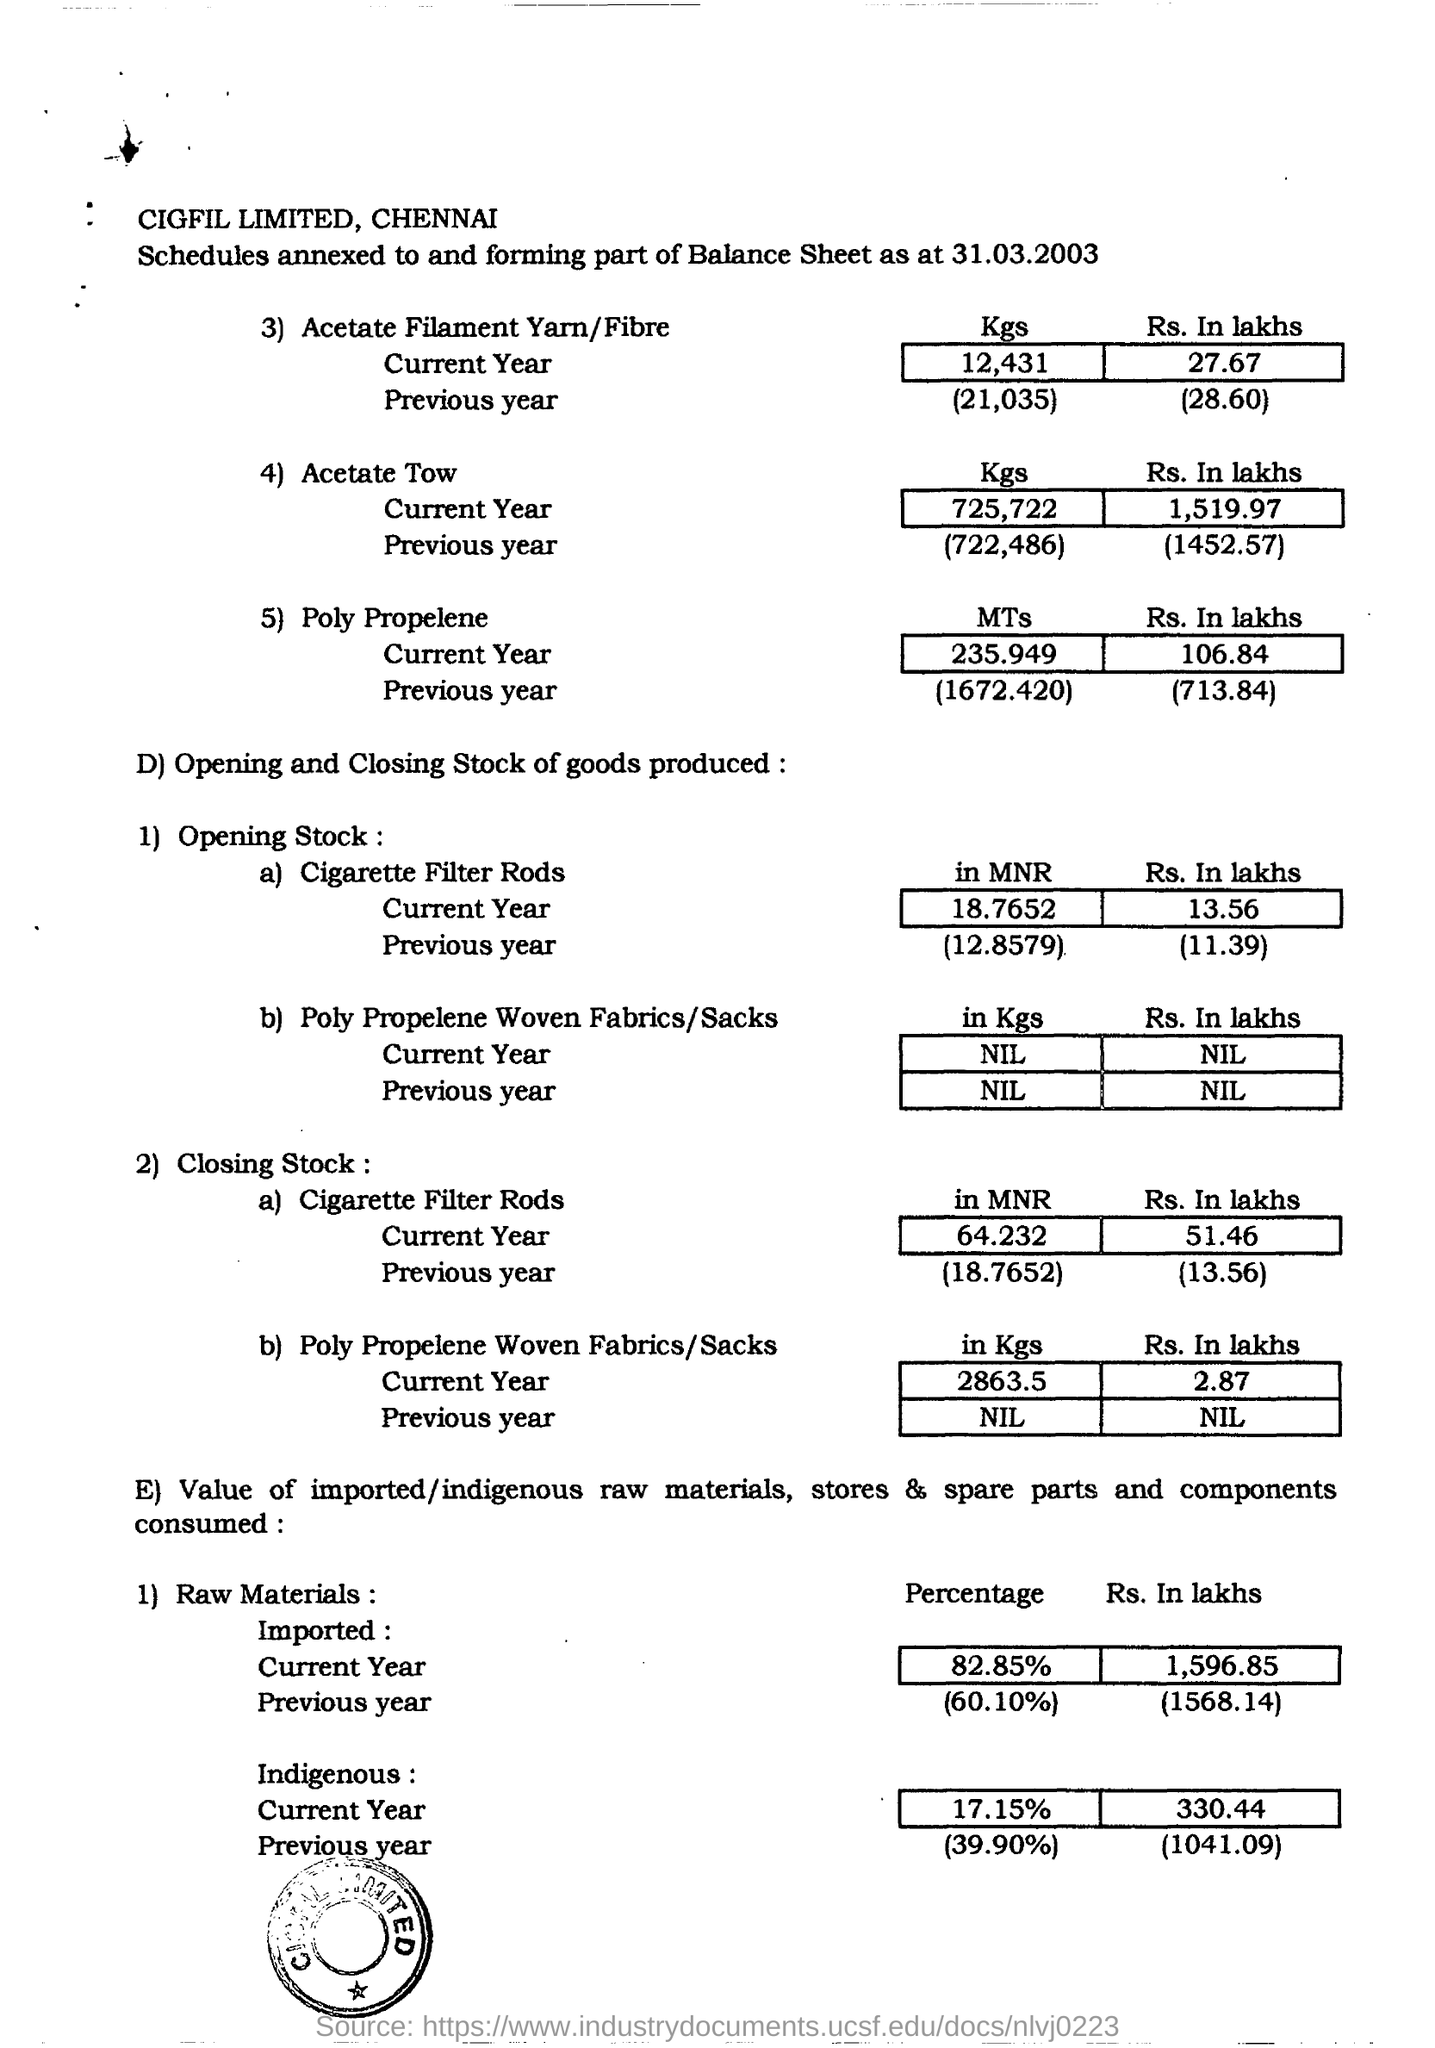What is the date mentioned in the document?
Offer a very short reply. 31.03.2003. What is the Percentage of Raw materials imported in the current year?
Make the answer very short. (82.85%). What is the Percentage of Raw materials imported in the previous year?
Provide a short and direct response. (60.10%). 